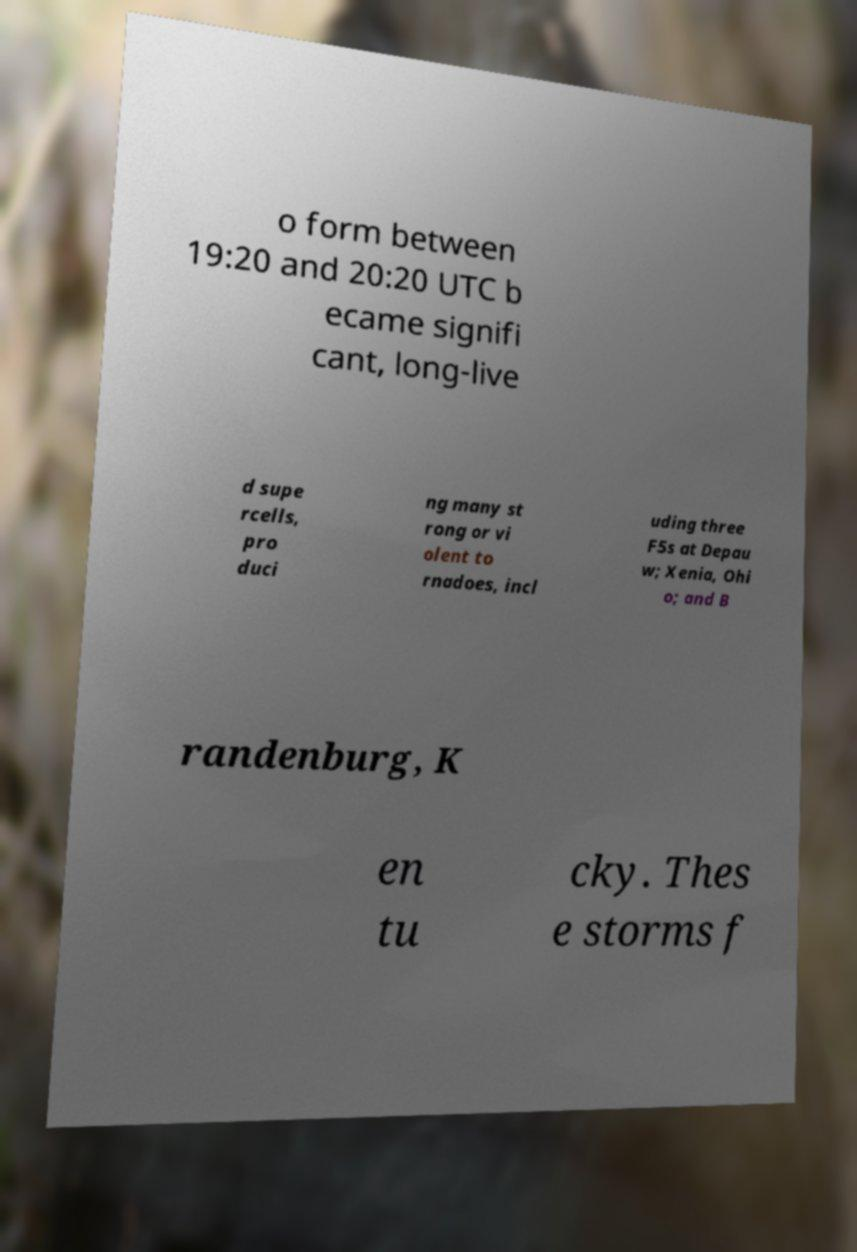For documentation purposes, I need the text within this image transcribed. Could you provide that? o form between 19:20 and 20:20 UTC b ecame signifi cant, long-live d supe rcells, pro duci ng many st rong or vi olent to rnadoes, incl uding three F5s at Depau w; Xenia, Ohi o; and B randenburg, K en tu cky. Thes e storms f 